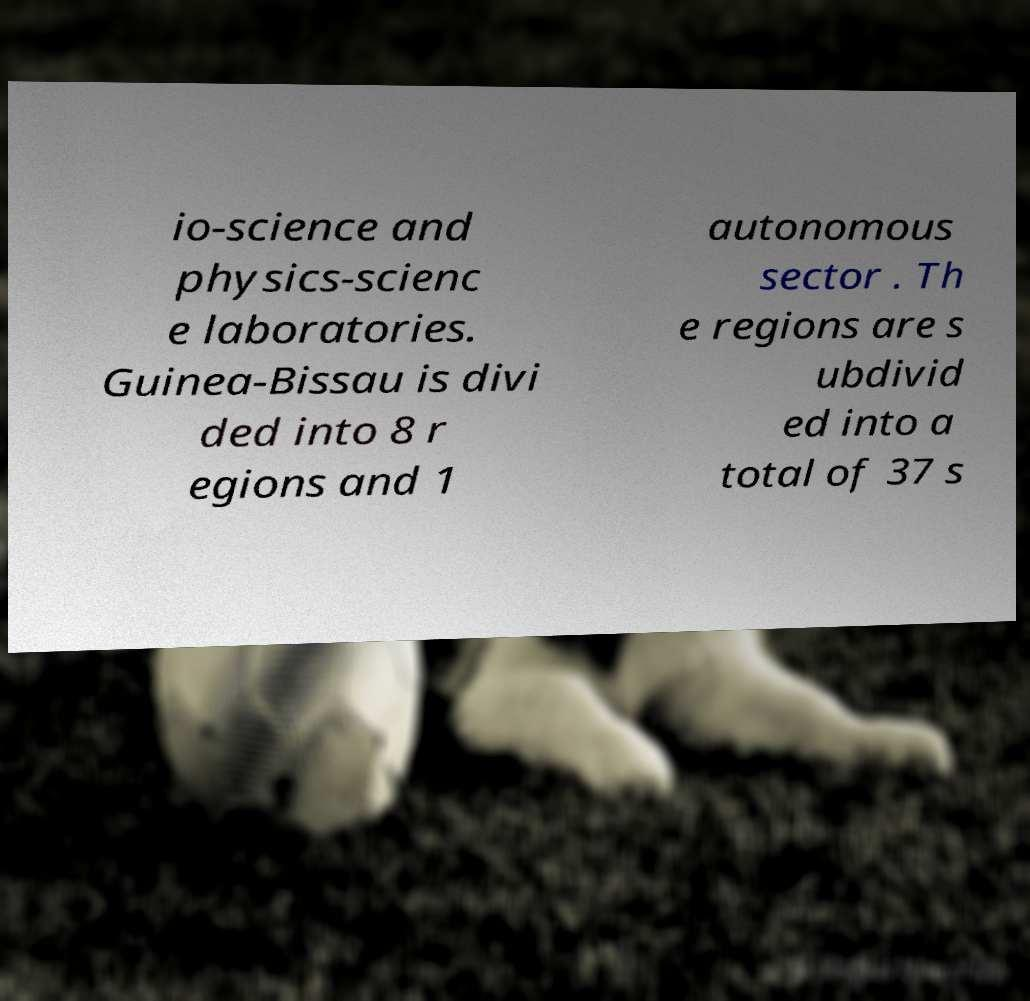There's text embedded in this image that I need extracted. Can you transcribe it verbatim? io-science and physics-scienc e laboratories. Guinea-Bissau is divi ded into 8 r egions and 1 autonomous sector . Th e regions are s ubdivid ed into a total of 37 s 